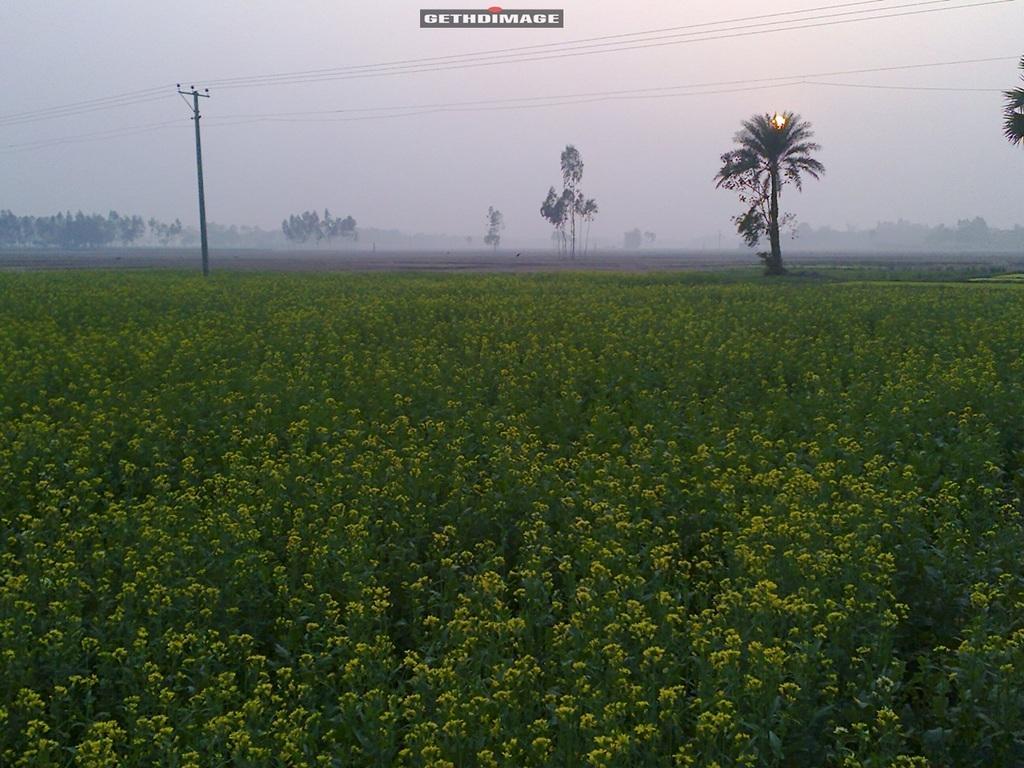How would you summarize this image in a sentence or two? In this picture we can see plants and an electric pole with the cables. Behind the pole there are trees and a sky. 